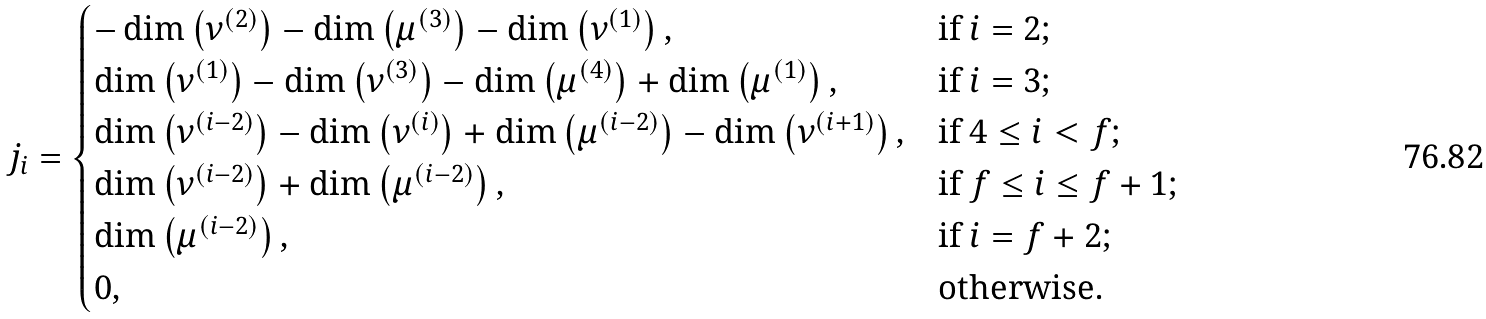<formula> <loc_0><loc_0><loc_500><loc_500>j _ { i } = \begin{cases} - \dim \left ( \nu ^ { ( 2 ) } \right ) - \dim \left ( \mu ^ { ( 3 ) } \right ) - \dim \left ( \nu ^ { ( 1 ) } \right ) , & \text {if $i=2$;} \\ \dim \left ( \nu ^ { ( 1 ) } \right ) - \dim \left ( \nu ^ { ( 3 ) } \right ) - \dim \left ( \mu ^ { ( 4 ) } \right ) + \dim \left ( \mu ^ { ( 1 ) } \right ) , & \text {if $i=3$;} \\ \dim \left ( \nu ^ { ( i - 2 ) } \right ) - \dim \left ( \nu ^ { ( i ) } \right ) + \dim \left ( \mu ^ { ( i - 2 ) } \right ) - \dim \left ( \nu ^ { ( i + 1 ) } \right ) , & \text {if $4\leq i <f$;} \\ \dim \left ( \nu ^ { ( i - 2 ) } \right ) + \dim \left ( \mu ^ { ( i - 2 ) } \right ) , & \text {if $f\leq i\leq f+1$;} \\ \dim \left ( \mu ^ { ( i - 2 ) } \right ) , & \text {if $i=f+2$;} \\ 0 , & \text {otherwise.} \end{cases}</formula> 